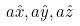Convert formula to latex. <formula><loc_0><loc_0><loc_500><loc_500>a \hat { x } , a \hat { y } , a \hat { z }</formula> 